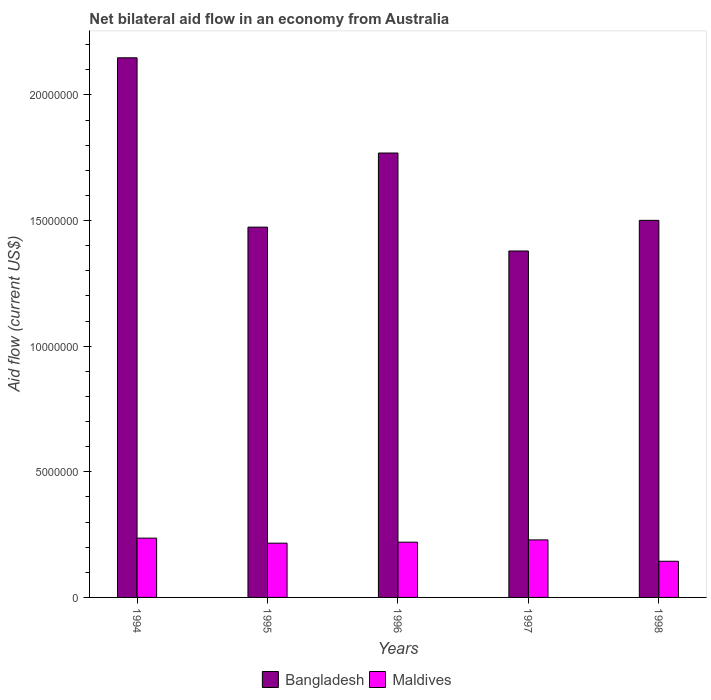How many groups of bars are there?
Ensure brevity in your answer.  5. How many bars are there on the 5th tick from the left?
Provide a succinct answer. 2. How many bars are there on the 3rd tick from the right?
Offer a very short reply. 2. What is the label of the 2nd group of bars from the left?
Provide a short and direct response. 1995. What is the net bilateral aid flow in Maldives in 1994?
Your response must be concise. 2.36e+06. Across all years, what is the maximum net bilateral aid flow in Maldives?
Offer a very short reply. 2.36e+06. Across all years, what is the minimum net bilateral aid flow in Maldives?
Keep it short and to the point. 1.44e+06. In which year was the net bilateral aid flow in Bangladesh maximum?
Ensure brevity in your answer.  1994. In which year was the net bilateral aid flow in Bangladesh minimum?
Provide a short and direct response. 1997. What is the total net bilateral aid flow in Maldives in the graph?
Your response must be concise. 1.04e+07. What is the difference between the net bilateral aid flow in Bangladesh in 1994 and the net bilateral aid flow in Maldives in 1995?
Your answer should be compact. 1.93e+07. What is the average net bilateral aid flow in Maldives per year?
Make the answer very short. 2.09e+06. In the year 1997, what is the difference between the net bilateral aid flow in Maldives and net bilateral aid flow in Bangladesh?
Offer a terse response. -1.15e+07. What is the ratio of the net bilateral aid flow in Maldives in 1995 to that in 1997?
Provide a short and direct response. 0.94. What is the difference between the highest and the second highest net bilateral aid flow in Maldives?
Give a very brief answer. 7.00e+04. What is the difference between the highest and the lowest net bilateral aid flow in Bangladesh?
Offer a very short reply. 7.69e+06. In how many years, is the net bilateral aid flow in Maldives greater than the average net bilateral aid flow in Maldives taken over all years?
Keep it short and to the point. 4. Is the sum of the net bilateral aid flow in Maldives in 1994 and 1997 greater than the maximum net bilateral aid flow in Bangladesh across all years?
Offer a terse response. No. What does the 1st bar from the left in 1997 represents?
Your response must be concise. Bangladesh. Are all the bars in the graph horizontal?
Offer a very short reply. No. How many years are there in the graph?
Your answer should be compact. 5. What is the difference between two consecutive major ticks on the Y-axis?
Make the answer very short. 5.00e+06. Are the values on the major ticks of Y-axis written in scientific E-notation?
Provide a succinct answer. No. Where does the legend appear in the graph?
Offer a very short reply. Bottom center. How many legend labels are there?
Give a very brief answer. 2. What is the title of the graph?
Your response must be concise. Net bilateral aid flow in an economy from Australia. What is the label or title of the Y-axis?
Provide a short and direct response. Aid flow (current US$). What is the Aid flow (current US$) in Bangladesh in 1994?
Your answer should be very brief. 2.15e+07. What is the Aid flow (current US$) of Maldives in 1994?
Your answer should be very brief. 2.36e+06. What is the Aid flow (current US$) in Bangladesh in 1995?
Offer a terse response. 1.47e+07. What is the Aid flow (current US$) of Maldives in 1995?
Your answer should be very brief. 2.16e+06. What is the Aid flow (current US$) of Bangladesh in 1996?
Make the answer very short. 1.77e+07. What is the Aid flow (current US$) in Maldives in 1996?
Provide a short and direct response. 2.20e+06. What is the Aid flow (current US$) of Bangladesh in 1997?
Provide a succinct answer. 1.38e+07. What is the Aid flow (current US$) of Maldives in 1997?
Offer a terse response. 2.29e+06. What is the Aid flow (current US$) of Bangladesh in 1998?
Offer a very short reply. 1.50e+07. What is the Aid flow (current US$) in Maldives in 1998?
Your answer should be compact. 1.44e+06. Across all years, what is the maximum Aid flow (current US$) of Bangladesh?
Offer a very short reply. 2.15e+07. Across all years, what is the maximum Aid flow (current US$) in Maldives?
Provide a succinct answer. 2.36e+06. Across all years, what is the minimum Aid flow (current US$) in Bangladesh?
Make the answer very short. 1.38e+07. Across all years, what is the minimum Aid flow (current US$) of Maldives?
Your response must be concise. 1.44e+06. What is the total Aid flow (current US$) in Bangladesh in the graph?
Your answer should be compact. 8.27e+07. What is the total Aid flow (current US$) of Maldives in the graph?
Offer a very short reply. 1.04e+07. What is the difference between the Aid flow (current US$) of Bangladesh in 1994 and that in 1995?
Offer a terse response. 6.74e+06. What is the difference between the Aid flow (current US$) in Maldives in 1994 and that in 1995?
Make the answer very short. 2.00e+05. What is the difference between the Aid flow (current US$) of Bangladesh in 1994 and that in 1996?
Your response must be concise. 3.79e+06. What is the difference between the Aid flow (current US$) in Maldives in 1994 and that in 1996?
Provide a succinct answer. 1.60e+05. What is the difference between the Aid flow (current US$) of Bangladesh in 1994 and that in 1997?
Your answer should be very brief. 7.69e+06. What is the difference between the Aid flow (current US$) of Maldives in 1994 and that in 1997?
Your response must be concise. 7.00e+04. What is the difference between the Aid flow (current US$) of Bangladesh in 1994 and that in 1998?
Provide a succinct answer. 6.47e+06. What is the difference between the Aid flow (current US$) in Maldives in 1994 and that in 1998?
Provide a succinct answer. 9.20e+05. What is the difference between the Aid flow (current US$) in Bangladesh in 1995 and that in 1996?
Keep it short and to the point. -2.95e+06. What is the difference between the Aid flow (current US$) in Maldives in 1995 and that in 1996?
Your answer should be compact. -4.00e+04. What is the difference between the Aid flow (current US$) of Bangladesh in 1995 and that in 1997?
Give a very brief answer. 9.50e+05. What is the difference between the Aid flow (current US$) in Bangladesh in 1995 and that in 1998?
Your response must be concise. -2.70e+05. What is the difference between the Aid flow (current US$) in Maldives in 1995 and that in 1998?
Make the answer very short. 7.20e+05. What is the difference between the Aid flow (current US$) of Bangladesh in 1996 and that in 1997?
Give a very brief answer. 3.90e+06. What is the difference between the Aid flow (current US$) in Maldives in 1996 and that in 1997?
Keep it short and to the point. -9.00e+04. What is the difference between the Aid flow (current US$) of Bangladesh in 1996 and that in 1998?
Provide a succinct answer. 2.68e+06. What is the difference between the Aid flow (current US$) of Maldives in 1996 and that in 1998?
Your answer should be compact. 7.60e+05. What is the difference between the Aid flow (current US$) of Bangladesh in 1997 and that in 1998?
Your response must be concise. -1.22e+06. What is the difference between the Aid flow (current US$) in Maldives in 1997 and that in 1998?
Your answer should be very brief. 8.50e+05. What is the difference between the Aid flow (current US$) of Bangladesh in 1994 and the Aid flow (current US$) of Maldives in 1995?
Offer a terse response. 1.93e+07. What is the difference between the Aid flow (current US$) in Bangladesh in 1994 and the Aid flow (current US$) in Maldives in 1996?
Ensure brevity in your answer.  1.93e+07. What is the difference between the Aid flow (current US$) of Bangladesh in 1994 and the Aid flow (current US$) of Maldives in 1997?
Give a very brief answer. 1.92e+07. What is the difference between the Aid flow (current US$) in Bangladesh in 1994 and the Aid flow (current US$) in Maldives in 1998?
Provide a short and direct response. 2.00e+07. What is the difference between the Aid flow (current US$) of Bangladesh in 1995 and the Aid flow (current US$) of Maldives in 1996?
Your answer should be compact. 1.25e+07. What is the difference between the Aid flow (current US$) of Bangladesh in 1995 and the Aid flow (current US$) of Maldives in 1997?
Ensure brevity in your answer.  1.24e+07. What is the difference between the Aid flow (current US$) in Bangladesh in 1995 and the Aid flow (current US$) in Maldives in 1998?
Your response must be concise. 1.33e+07. What is the difference between the Aid flow (current US$) in Bangladesh in 1996 and the Aid flow (current US$) in Maldives in 1997?
Offer a very short reply. 1.54e+07. What is the difference between the Aid flow (current US$) in Bangladesh in 1996 and the Aid flow (current US$) in Maldives in 1998?
Your response must be concise. 1.62e+07. What is the difference between the Aid flow (current US$) of Bangladesh in 1997 and the Aid flow (current US$) of Maldives in 1998?
Your answer should be very brief. 1.24e+07. What is the average Aid flow (current US$) of Bangladesh per year?
Offer a terse response. 1.65e+07. What is the average Aid flow (current US$) in Maldives per year?
Offer a very short reply. 2.09e+06. In the year 1994, what is the difference between the Aid flow (current US$) in Bangladesh and Aid flow (current US$) in Maldives?
Ensure brevity in your answer.  1.91e+07. In the year 1995, what is the difference between the Aid flow (current US$) in Bangladesh and Aid flow (current US$) in Maldives?
Provide a short and direct response. 1.26e+07. In the year 1996, what is the difference between the Aid flow (current US$) in Bangladesh and Aid flow (current US$) in Maldives?
Keep it short and to the point. 1.55e+07. In the year 1997, what is the difference between the Aid flow (current US$) in Bangladesh and Aid flow (current US$) in Maldives?
Keep it short and to the point. 1.15e+07. In the year 1998, what is the difference between the Aid flow (current US$) in Bangladesh and Aid flow (current US$) in Maldives?
Offer a very short reply. 1.36e+07. What is the ratio of the Aid flow (current US$) in Bangladesh in 1994 to that in 1995?
Provide a short and direct response. 1.46. What is the ratio of the Aid flow (current US$) of Maldives in 1994 to that in 1995?
Keep it short and to the point. 1.09. What is the ratio of the Aid flow (current US$) of Bangladesh in 1994 to that in 1996?
Ensure brevity in your answer.  1.21. What is the ratio of the Aid flow (current US$) of Maldives in 1994 to that in 1996?
Give a very brief answer. 1.07. What is the ratio of the Aid flow (current US$) in Bangladesh in 1994 to that in 1997?
Ensure brevity in your answer.  1.56. What is the ratio of the Aid flow (current US$) in Maldives in 1994 to that in 1997?
Give a very brief answer. 1.03. What is the ratio of the Aid flow (current US$) in Bangladesh in 1994 to that in 1998?
Provide a succinct answer. 1.43. What is the ratio of the Aid flow (current US$) in Maldives in 1994 to that in 1998?
Your answer should be very brief. 1.64. What is the ratio of the Aid flow (current US$) of Bangladesh in 1995 to that in 1996?
Ensure brevity in your answer.  0.83. What is the ratio of the Aid flow (current US$) in Maldives in 1995 to that in 1996?
Provide a succinct answer. 0.98. What is the ratio of the Aid flow (current US$) in Bangladesh in 1995 to that in 1997?
Provide a succinct answer. 1.07. What is the ratio of the Aid flow (current US$) of Maldives in 1995 to that in 1997?
Ensure brevity in your answer.  0.94. What is the ratio of the Aid flow (current US$) of Bangladesh in 1995 to that in 1998?
Offer a very short reply. 0.98. What is the ratio of the Aid flow (current US$) in Maldives in 1995 to that in 1998?
Give a very brief answer. 1.5. What is the ratio of the Aid flow (current US$) in Bangladesh in 1996 to that in 1997?
Your response must be concise. 1.28. What is the ratio of the Aid flow (current US$) in Maldives in 1996 to that in 1997?
Ensure brevity in your answer.  0.96. What is the ratio of the Aid flow (current US$) of Bangladesh in 1996 to that in 1998?
Offer a terse response. 1.18. What is the ratio of the Aid flow (current US$) of Maldives in 1996 to that in 1998?
Your answer should be compact. 1.53. What is the ratio of the Aid flow (current US$) of Bangladesh in 1997 to that in 1998?
Ensure brevity in your answer.  0.92. What is the ratio of the Aid flow (current US$) in Maldives in 1997 to that in 1998?
Give a very brief answer. 1.59. What is the difference between the highest and the second highest Aid flow (current US$) of Bangladesh?
Your answer should be very brief. 3.79e+06. What is the difference between the highest and the lowest Aid flow (current US$) of Bangladesh?
Provide a short and direct response. 7.69e+06. What is the difference between the highest and the lowest Aid flow (current US$) in Maldives?
Offer a terse response. 9.20e+05. 